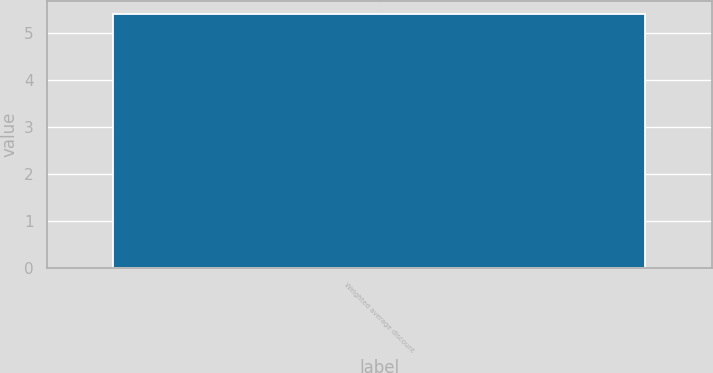<chart> <loc_0><loc_0><loc_500><loc_500><bar_chart><fcel>Weighted average discount<nl><fcel>5.4<nl></chart> 